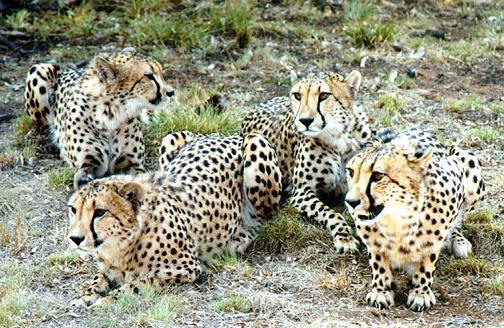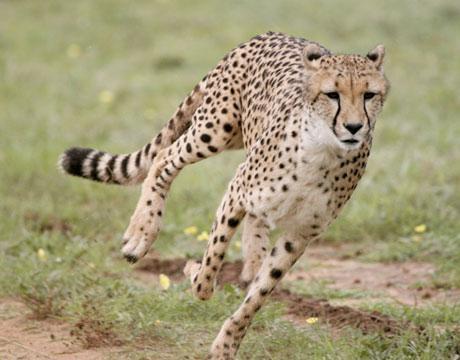The first image is the image on the left, the second image is the image on the right. Analyze the images presented: Is the assertion "There are at least five cheetah in the pair of images." valid? Answer yes or no. Yes. The first image is the image on the left, the second image is the image on the right. For the images shown, is this caption "The left image contains at least four cheetahs." true? Answer yes or no. Yes. 